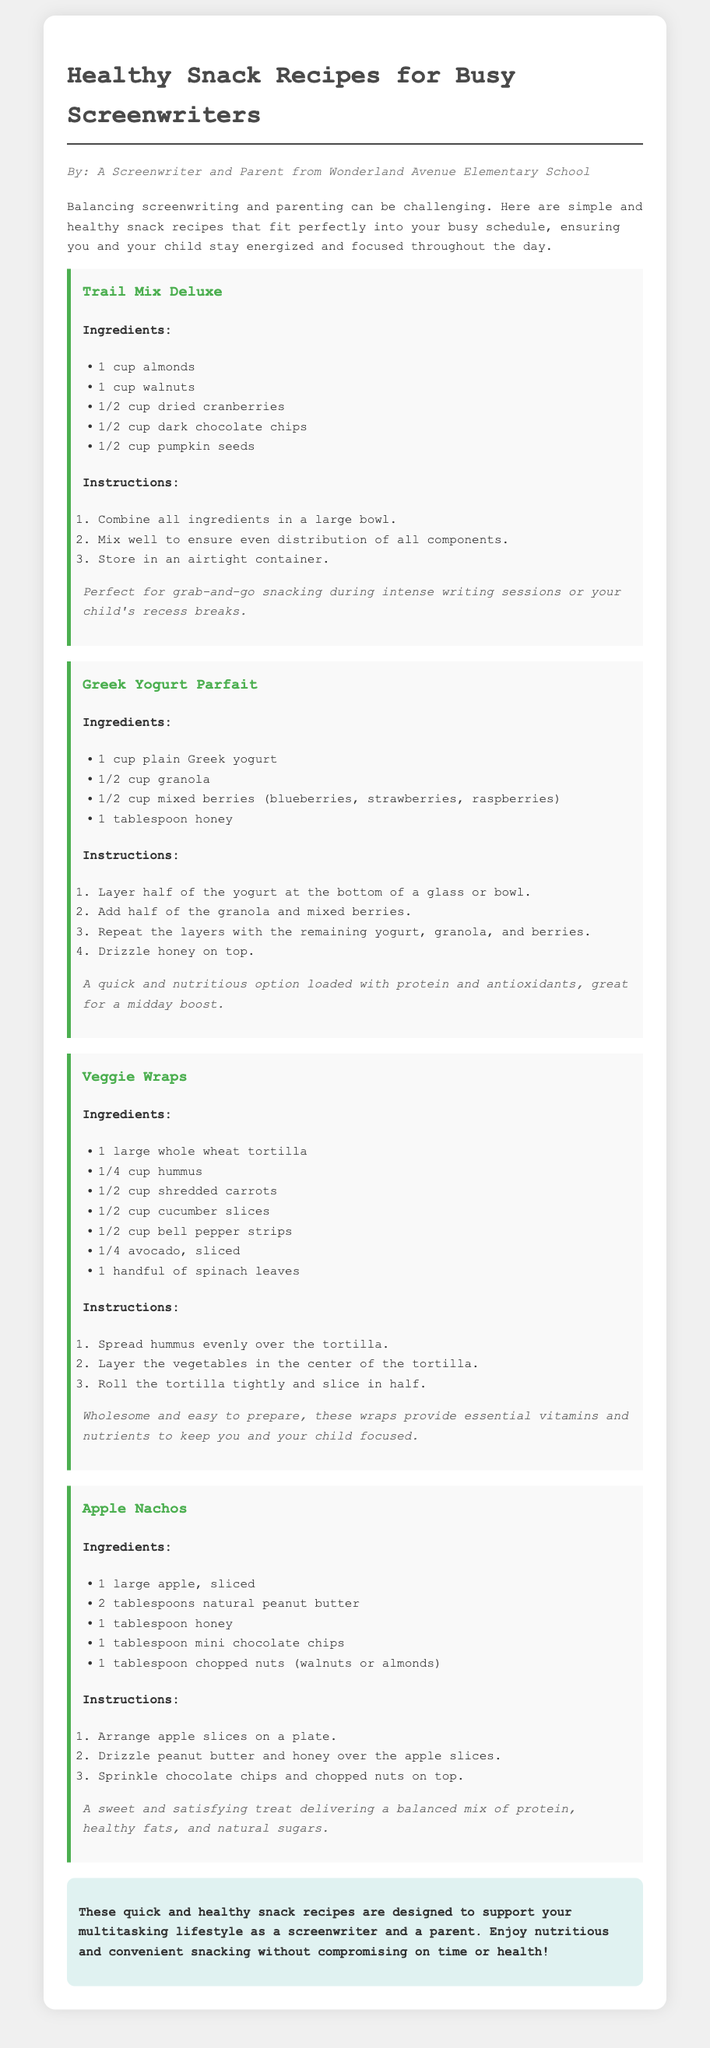What is the first recipe listed? The first recipe in the document is identified by its title, which is the beginning of the recipes section.
Answer: Trail Mix Deluxe How many ingredients are in the Greek Yogurt Parfait? The Greek Yogurt Parfait lists four ingredients in its ingredient section.
Answer: 4 What type of tortilla is used in the Veggie Wraps? The document specifies that a large whole wheat tortilla is used for the Veggie Wraps.
Answer: Whole wheat What is the sweetener used in the Apple Nachos? The Apple Nachos recipe includes honey as a sweetener among its ingredients.
Answer: Honey What is the main protein source in the Trail Mix Deluxe? The main protein sources are found in the first recipe's ingredients, prominently mentioned are almonds and walnuts.
Answer: Almonds and walnuts Which recipe includes avocado? The Veggie Wraps recipe is the only one that includes avocado in its list of ingredients.
Answer: Veggie Wraps How many steps are there in the instructions for making Apple Nachos? The instructions for Apple Nachos contain three steps.
Answer: 3 What is the total number of recipes included in this document? The document features a total of four distinct recipes.
Answer: 4 Which recipe is suggested for a midday boost? The Greek Yogurt Parfait is noted in the document as a quick option for a midday energy boost.
Answer: Greek Yogurt Parfait 